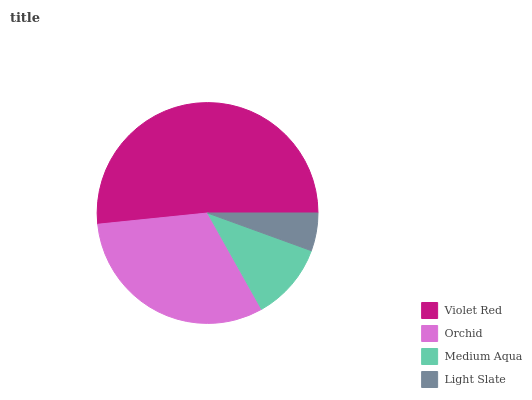Is Light Slate the minimum?
Answer yes or no. Yes. Is Violet Red the maximum?
Answer yes or no. Yes. Is Orchid the minimum?
Answer yes or no. No. Is Orchid the maximum?
Answer yes or no. No. Is Violet Red greater than Orchid?
Answer yes or no. Yes. Is Orchid less than Violet Red?
Answer yes or no. Yes. Is Orchid greater than Violet Red?
Answer yes or no. No. Is Violet Red less than Orchid?
Answer yes or no. No. Is Orchid the high median?
Answer yes or no. Yes. Is Medium Aqua the low median?
Answer yes or no. Yes. Is Medium Aqua the high median?
Answer yes or no. No. Is Orchid the low median?
Answer yes or no. No. 